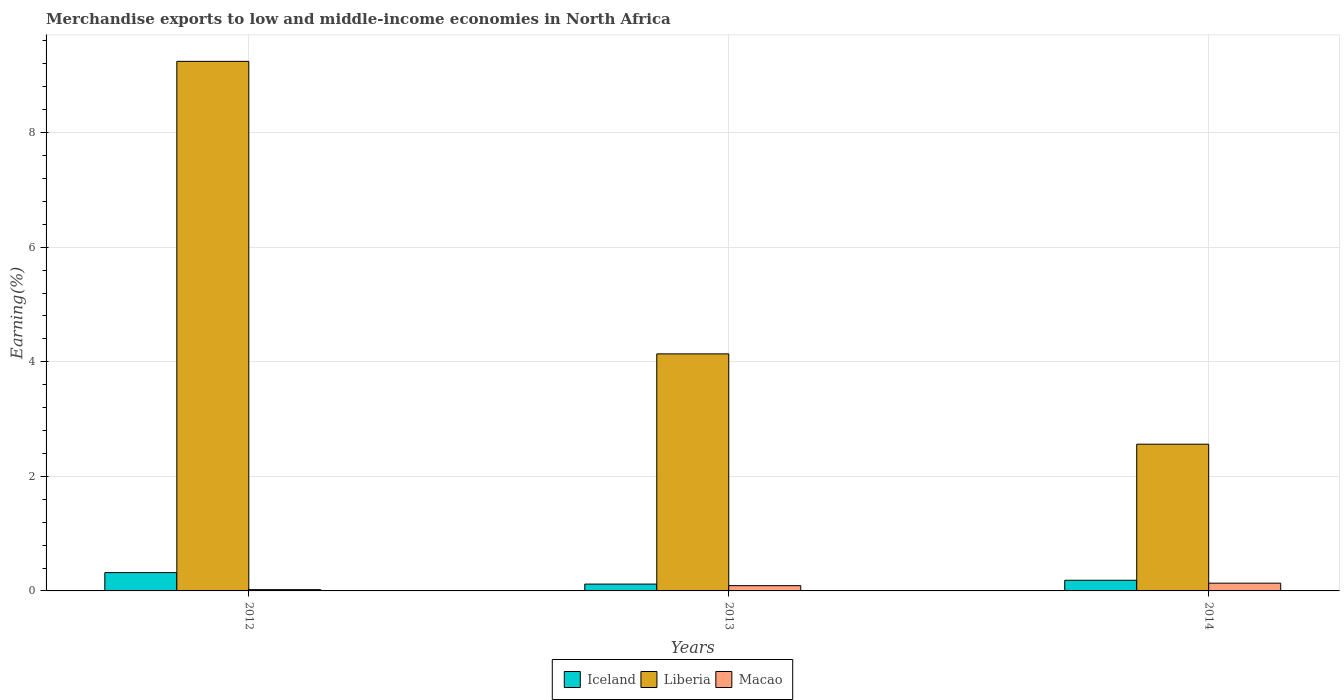Are the number of bars per tick equal to the number of legend labels?
Make the answer very short. Yes. How many bars are there on the 2nd tick from the left?
Provide a succinct answer. 3. What is the label of the 1st group of bars from the left?
Provide a short and direct response. 2012. In how many cases, is the number of bars for a given year not equal to the number of legend labels?
Give a very brief answer. 0. What is the percentage of amount earned from merchandise exports in Liberia in 2014?
Make the answer very short. 2.56. Across all years, what is the maximum percentage of amount earned from merchandise exports in Iceland?
Ensure brevity in your answer.  0.32. Across all years, what is the minimum percentage of amount earned from merchandise exports in Macao?
Make the answer very short. 0.02. In which year was the percentage of amount earned from merchandise exports in Liberia maximum?
Provide a succinct answer. 2012. In which year was the percentage of amount earned from merchandise exports in Liberia minimum?
Offer a terse response. 2014. What is the total percentage of amount earned from merchandise exports in Macao in the graph?
Give a very brief answer. 0.25. What is the difference between the percentage of amount earned from merchandise exports in Iceland in 2012 and that in 2013?
Offer a terse response. 0.2. What is the difference between the percentage of amount earned from merchandise exports in Liberia in 2014 and the percentage of amount earned from merchandise exports in Macao in 2012?
Your answer should be very brief. 2.54. What is the average percentage of amount earned from merchandise exports in Iceland per year?
Provide a succinct answer. 0.21. In the year 2014, what is the difference between the percentage of amount earned from merchandise exports in Macao and percentage of amount earned from merchandise exports in Liberia?
Your response must be concise. -2.43. In how many years, is the percentage of amount earned from merchandise exports in Macao greater than 6.4 %?
Keep it short and to the point. 0. What is the ratio of the percentage of amount earned from merchandise exports in Liberia in 2012 to that in 2014?
Provide a succinct answer. 3.61. Is the percentage of amount earned from merchandise exports in Liberia in 2012 less than that in 2014?
Provide a short and direct response. No. Is the difference between the percentage of amount earned from merchandise exports in Macao in 2012 and 2014 greater than the difference between the percentage of amount earned from merchandise exports in Liberia in 2012 and 2014?
Make the answer very short. No. What is the difference between the highest and the second highest percentage of amount earned from merchandise exports in Iceland?
Your answer should be compact. 0.13. What is the difference between the highest and the lowest percentage of amount earned from merchandise exports in Macao?
Offer a very short reply. 0.11. In how many years, is the percentage of amount earned from merchandise exports in Macao greater than the average percentage of amount earned from merchandise exports in Macao taken over all years?
Your answer should be very brief. 2. What does the 3rd bar from the left in 2014 represents?
Offer a terse response. Macao. What does the 1st bar from the right in 2013 represents?
Provide a succinct answer. Macao. How many bars are there?
Your answer should be compact. 9. Are the values on the major ticks of Y-axis written in scientific E-notation?
Make the answer very short. No. Where does the legend appear in the graph?
Give a very brief answer. Bottom center. How are the legend labels stacked?
Keep it short and to the point. Horizontal. What is the title of the graph?
Provide a succinct answer. Merchandise exports to low and middle-income economies in North Africa. Does "Sint Maarten (Dutch part)" appear as one of the legend labels in the graph?
Offer a very short reply. No. What is the label or title of the Y-axis?
Offer a terse response. Earning(%). What is the Earning(%) in Iceland in 2012?
Provide a succinct answer. 0.32. What is the Earning(%) of Liberia in 2012?
Your response must be concise. 9.24. What is the Earning(%) of Macao in 2012?
Ensure brevity in your answer.  0.02. What is the Earning(%) of Iceland in 2013?
Provide a short and direct response. 0.12. What is the Earning(%) of Liberia in 2013?
Keep it short and to the point. 4.14. What is the Earning(%) of Macao in 2013?
Make the answer very short. 0.09. What is the Earning(%) in Iceland in 2014?
Offer a terse response. 0.19. What is the Earning(%) in Liberia in 2014?
Provide a short and direct response. 2.56. What is the Earning(%) of Macao in 2014?
Provide a succinct answer. 0.14. Across all years, what is the maximum Earning(%) of Iceland?
Provide a short and direct response. 0.32. Across all years, what is the maximum Earning(%) in Liberia?
Your answer should be compact. 9.24. Across all years, what is the maximum Earning(%) in Macao?
Your answer should be compact. 0.14. Across all years, what is the minimum Earning(%) in Iceland?
Offer a very short reply. 0.12. Across all years, what is the minimum Earning(%) in Liberia?
Your answer should be compact. 2.56. Across all years, what is the minimum Earning(%) of Macao?
Give a very brief answer. 0.02. What is the total Earning(%) of Iceland in the graph?
Ensure brevity in your answer.  0.63. What is the total Earning(%) of Liberia in the graph?
Ensure brevity in your answer.  15.94. What is the total Earning(%) of Macao in the graph?
Provide a short and direct response. 0.25. What is the difference between the Earning(%) of Iceland in 2012 and that in 2013?
Your answer should be very brief. 0.2. What is the difference between the Earning(%) of Liberia in 2012 and that in 2013?
Provide a succinct answer. 5.11. What is the difference between the Earning(%) of Macao in 2012 and that in 2013?
Your answer should be compact. -0.07. What is the difference between the Earning(%) of Iceland in 2012 and that in 2014?
Provide a short and direct response. 0.13. What is the difference between the Earning(%) in Liberia in 2012 and that in 2014?
Keep it short and to the point. 6.68. What is the difference between the Earning(%) of Macao in 2012 and that in 2014?
Offer a terse response. -0.11. What is the difference between the Earning(%) in Iceland in 2013 and that in 2014?
Your answer should be very brief. -0.07. What is the difference between the Earning(%) in Liberia in 2013 and that in 2014?
Make the answer very short. 1.58. What is the difference between the Earning(%) in Macao in 2013 and that in 2014?
Provide a succinct answer. -0.04. What is the difference between the Earning(%) of Iceland in 2012 and the Earning(%) of Liberia in 2013?
Your answer should be compact. -3.82. What is the difference between the Earning(%) of Iceland in 2012 and the Earning(%) of Macao in 2013?
Ensure brevity in your answer.  0.23. What is the difference between the Earning(%) in Liberia in 2012 and the Earning(%) in Macao in 2013?
Offer a very short reply. 9.15. What is the difference between the Earning(%) in Iceland in 2012 and the Earning(%) in Liberia in 2014?
Give a very brief answer. -2.24. What is the difference between the Earning(%) in Iceland in 2012 and the Earning(%) in Macao in 2014?
Give a very brief answer. 0.18. What is the difference between the Earning(%) in Liberia in 2012 and the Earning(%) in Macao in 2014?
Your response must be concise. 9.11. What is the difference between the Earning(%) in Iceland in 2013 and the Earning(%) in Liberia in 2014?
Provide a succinct answer. -2.44. What is the difference between the Earning(%) of Iceland in 2013 and the Earning(%) of Macao in 2014?
Keep it short and to the point. -0.02. What is the difference between the Earning(%) in Liberia in 2013 and the Earning(%) in Macao in 2014?
Offer a very short reply. 4. What is the average Earning(%) in Iceland per year?
Make the answer very short. 0.21. What is the average Earning(%) in Liberia per year?
Provide a short and direct response. 5.31. What is the average Earning(%) in Macao per year?
Offer a terse response. 0.08. In the year 2012, what is the difference between the Earning(%) of Iceland and Earning(%) of Liberia?
Ensure brevity in your answer.  -8.92. In the year 2012, what is the difference between the Earning(%) in Iceland and Earning(%) in Macao?
Make the answer very short. 0.3. In the year 2012, what is the difference between the Earning(%) in Liberia and Earning(%) in Macao?
Offer a terse response. 9.22. In the year 2013, what is the difference between the Earning(%) of Iceland and Earning(%) of Liberia?
Offer a very short reply. -4.02. In the year 2013, what is the difference between the Earning(%) in Iceland and Earning(%) in Macao?
Ensure brevity in your answer.  0.03. In the year 2013, what is the difference between the Earning(%) in Liberia and Earning(%) in Macao?
Your answer should be compact. 4.05. In the year 2014, what is the difference between the Earning(%) of Iceland and Earning(%) of Liberia?
Offer a terse response. -2.38. In the year 2014, what is the difference between the Earning(%) of Iceland and Earning(%) of Macao?
Offer a very short reply. 0.05. In the year 2014, what is the difference between the Earning(%) of Liberia and Earning(%) of Macao?
Offer a very short reply. 2.43. What is the ratio of the Earning(%) of Iceland in 2012 to that in 2013?
Keep it short and to the point. 2.68. What is the ratio of the Earning(%) of Liberia in 2012 to that in 2013?
Keep it short and to the point. 2.23. What is the ratio of the Earning(%) of Macao in 2012 to that in 2013?
Give a very brief answer. 0.24. What is the ratio of the Earning(%) in Iceland in 2012 to that in 2014?
Keep it short and to the point. 1.72. What is the ratio of the Earning(%) in Liberia in 2012 to that in 2014?
Provide a succinct answer. 3.61. What is the ratio of the Earning(%) of Macao in 2012 to that in 2014?
Make the answer very short. 0.17. What is the ratio of the Earning(%) in Iceland in 2013 to that in 2014?
Your response must be concise. 0.64. What is the ratio of the Earning(%) of Liberia in 2013 to that in 2014?
Make the answer very short. 1.62. What is the ratio of the Earning(%) of Macao in 2013 to that in 2014?
Your response must be concise. 0.68. What is the difference between the highest and the second highest Earning(%) in Iceland?
Offer a terse response. 0.13. What is the difference between the highest and the second highest Earning(%) of Liberia?
Ensure brevity in your answer.  5.11. What is the difference between the highest and the second highest Earning(%) of Macao?
Offer a very short reply. 0.04. What is the difference between the highest and the lowest Earning(%) in Iceland?
Ensure brevity in your answer.  0.2. What is the difference between the highest and the lowest Earning(%) of Liberia?
Make the answer very short. 6.68. What is the difference between the highest and the lowest Earning(%) in Macao?
Give a very brief answer. 0.11. 